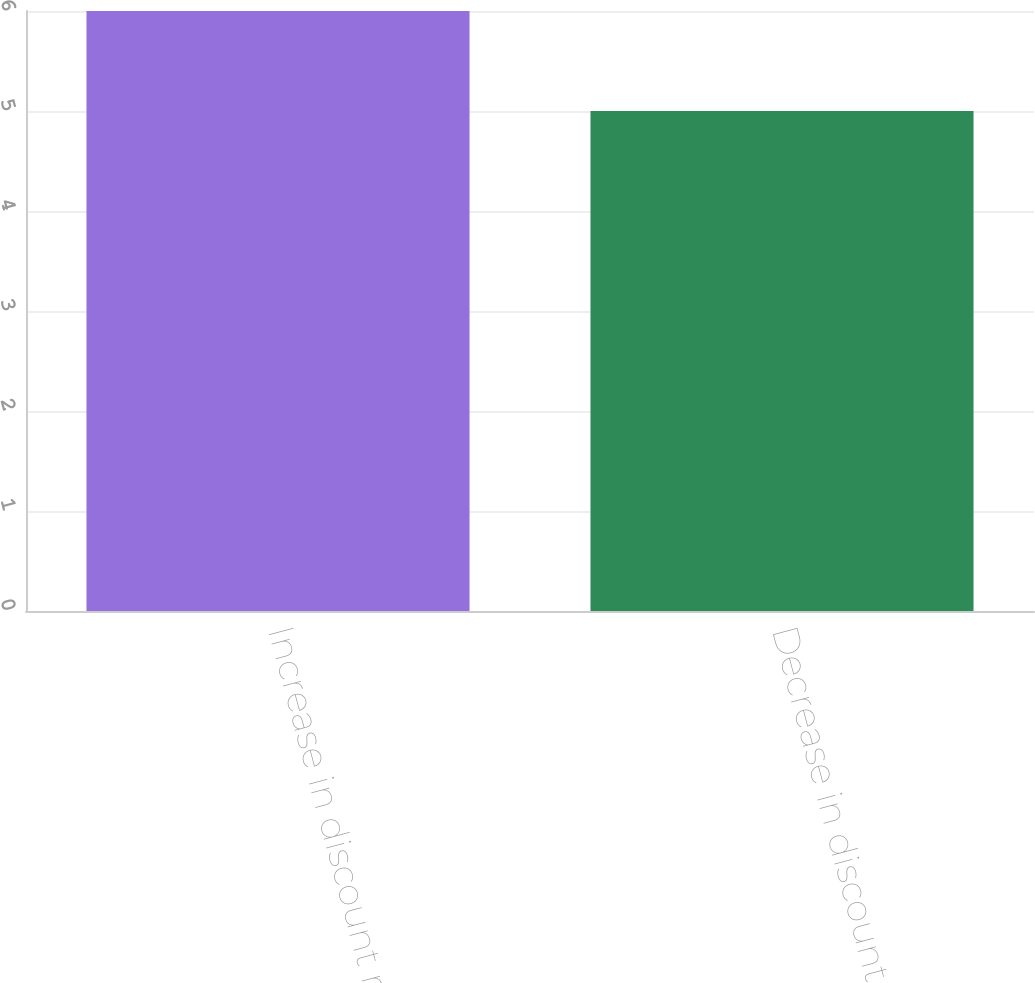<chart> <loc_0><loc_0><loc_500><loc_500><bar_chart><fcel>Increase in discount rate by<fcel>Decrease in discount rate by<nl><fcel>6<fcel>5<nl></chart> 